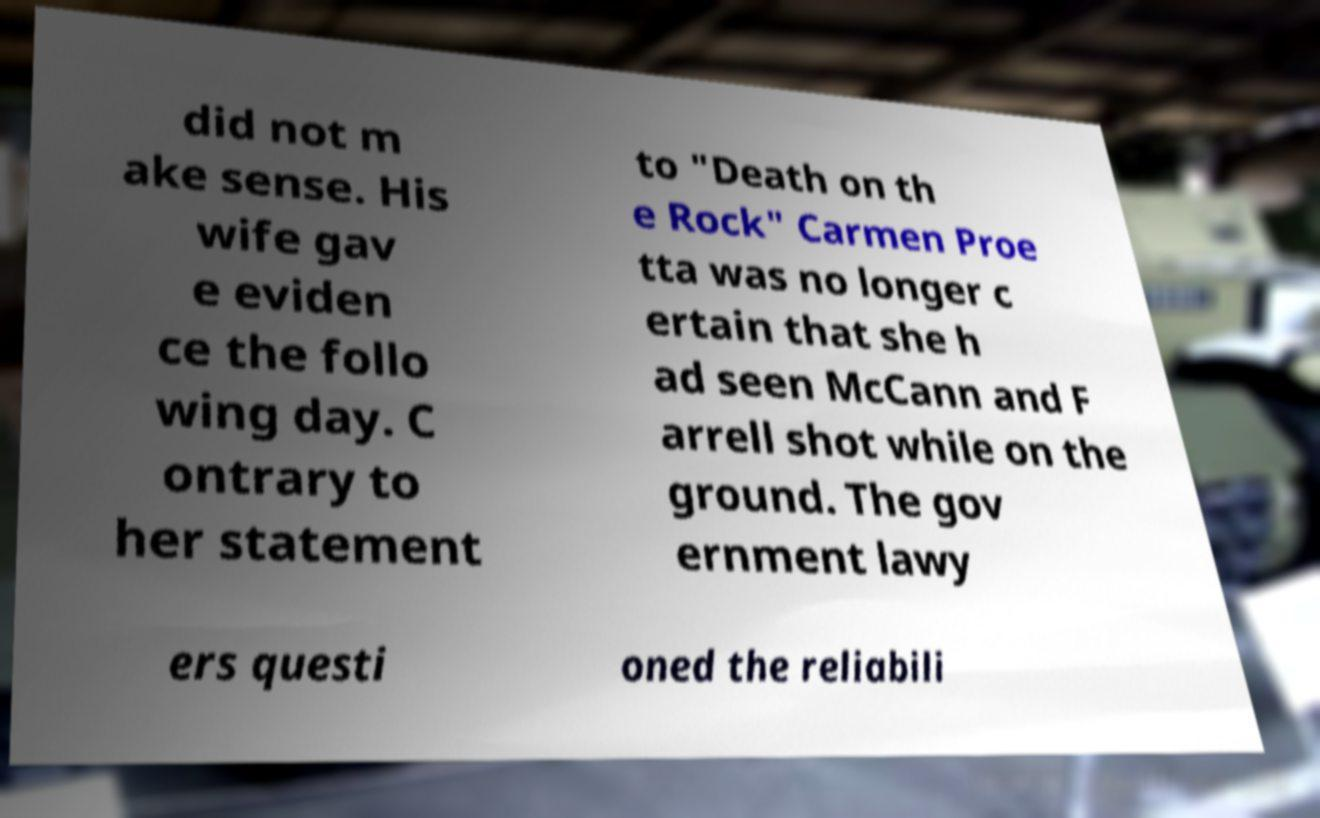For documentation purposes, I need the text within this image transcribed. Could you provide that? did not m ake sense. His wife gav e eviden ce the follo wing day. C ontrary to her statement to "Death on th e Rock" Carmen Proe tta was no longer c ertain that she h ad seen McCann and F arrell shot while on the ground. The gov ernment lawy ers questi oned the reliabili 